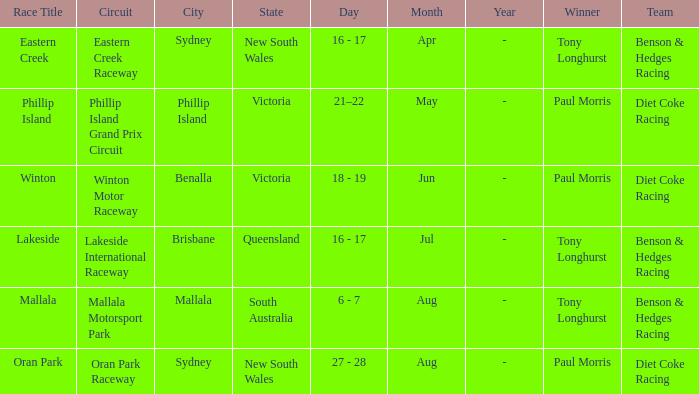When was the mallala contest conducted? 6 - 7 Aug. 